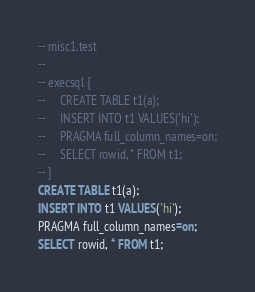<code> <loc_0><loc_0><loc_500><loc_500><_SQL_>-- misc1.test
-- 
-- execsql {
--     CREATE TABLE t1(a);
--     INSERT INTO t1 VALUES('hi');
--     PRAGMA full_column_names=on;
--     SELECT rowid, * FROM t1;
-- }
CREATE TABLE t1(a);
INSERT INTO t1 VALUES('hi');
PRAGMA full_column_names=on;
SELECT rowid, * FROM t1;</code> 